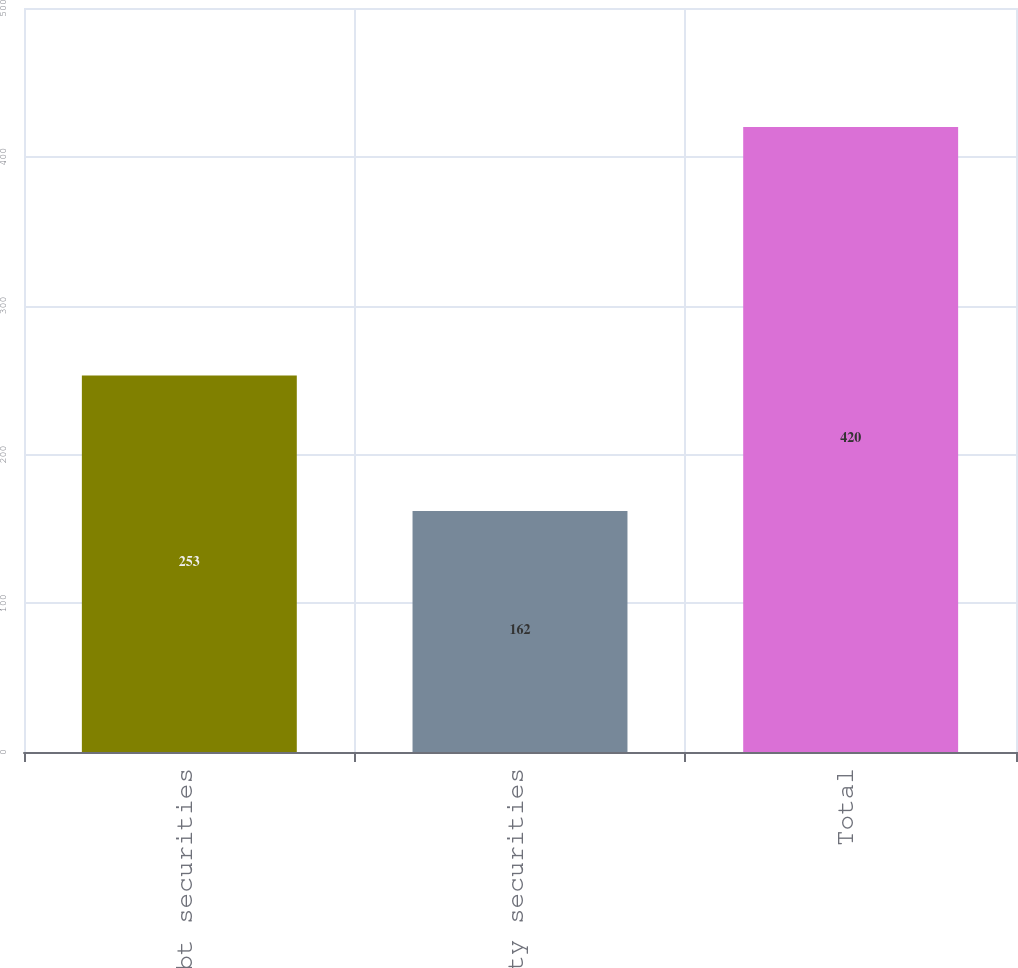Convert chart. <chart><loc_0><loc_0><loc_500><loc_500><bar_chart><fcel>Debt securities<fcel>Equity securities<fcel>Total<nl><fcel>253<fcel>162<fcel>420<nl></chart> 